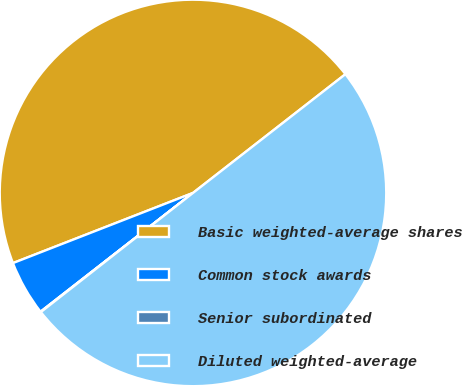Convert chart. <chart><loc_0><loc_0><loc_500><loc_500><pie_chart><fcel>Basic weighted-average shares<fcel>Common stock awards<fcel>Senior subordinated<fcel>Diluted weighted-average<nl><fcel>45.38%<fcel>4.62%<fcel>0.04%<fcel>49.96%<nl></chart> 